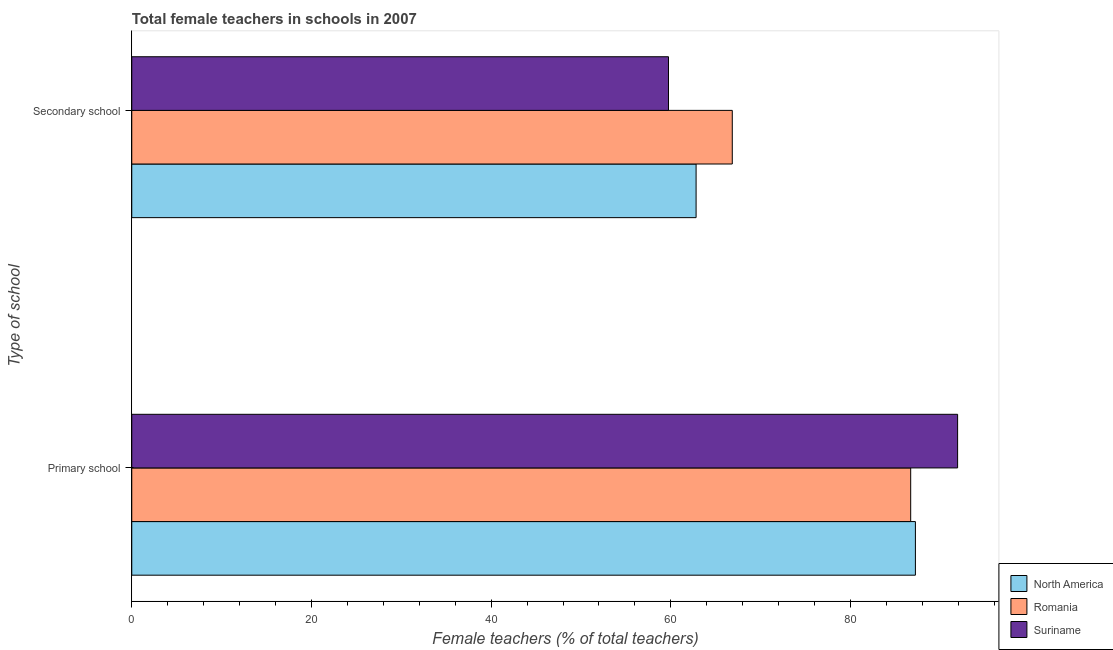How many different coloured bars are there?
Your answer should be very brief. 3. Are the number of bars per tick equal to the number of legend labels?
Your answer should be compact. Yes. Are the number of bars on each tick of the Y-axis equal?
Provide a short and direct response. Yes. How many bars are there on the 2nd tick from the bottom?
Ensure brevity in your answer.  3. What is the label of the 1st group of bars from the top?
Provide a short and direct response. Secondary school. What is the percentage of female teachers in primary schools in Romania?
Offer a terse response. 86.7. Across all countries, what is the maximum percentage of female teachers in primary schools?
Your answer should be very brief. 91.92. Across all countries, what is the minimum percentage of female teachers in primary schools?
Your answer should be very brief. 86.7. In which country was the percentage of female teachers in secondary schools maximum?
Give a very brief answer. Romania. In which country was the percentage of female teachers in secondary schools minimum?
Your response must be concise. Suriname. What is the total percentage of female teachers in secondary schools in the graph?
Offer a very short reply. 189.39. What is the difference between the percentage of female teachers in secondary schools in North America and that in Romania?
Keep it short and to the point. -4.03. What is the difference between the percentage of female teachers in secondary schools in North America and the percentage of female teachers in primary schools in Romania?
Give a very brief answer. -23.89. What is the average percentage of female teachers in primary schools per country?
Offer a terse response. 88.61. What is the difference between the percentage of female teachers in primary schools and percentage of female teachers in secondary schools in Suriname?
Make the answer very short. 32.18. What is the ratio of the percentage of female teachers in primary schools in North America to that in Romania?
Make the answer very short. 1.01. What does the 3rd bar from the top in Primary school represents?
Offer a very short reply. North America. What does the 3rd bar from the bottom in Primary school represents?
Keep it short and to the point. Suriname. How many bars are there?
Your answer should be very brief. 6. What is the difference between two consecutive major ticks on the X-axis?
Make the answer very short. 20. Are the values on the major ticks of X-axis written in scientific E-notation?
Keep it short and to the point. No. Does the graph contain any zero values?
Give a very brief answer. No. Does the graph contain grids?
Keep it short and to the point. No. How many legend labels are there?
Provide a short and direct response. 3. How are the legend labels stacked?
Provide a short and direct response. Vertical. What is the title of the graph?
Offer a very short reply. Total female teachers in schools in 2007. Does "Japan" appear as one of the legend labels in the graph?
Offer a terse response. No. What is the label or title of the X-axis?
Offer a very short reply. Female teachers (% of total teachers). What is the label or title of the Y-axis?
Make the answer very short. Type of school. What is the Female teachers (% of total teachers) in North America in Primary school?
Keep it short and to the point. 87.22. What is the Female teachers (% of total teachers) in Romania in Primary school?
Make the answer very short. 86.7. What is the Female teachers (% of total teachers) of Suriname in Primary school?
Keep it short and to the point. 91.92. What is the Female teachers (% of total teachers) of North America in Secondary school?
Your answer should be compact. 62.81. What is the Female teachers (% of total teachers) in Romania in Secondary school?
Your answer should be compact. 66.84. What is the Female teachers (% of total teachers) in Suriname in Secondary school?
Give a very brief answer. 59.74. Across all Type of school, what is the maximum Female teachers (% of total teachers) of North America?
Your answer should be very brief. 87.22. Across all Type of school, what is the maximum Female teachers (% of total teachers) in Romania?
Offer a terse response. 86.7. Across all Type of school, what is the maximum Female teachers (% of total teachers) of Suriname?
Make the answer very short. 91.92. Across all Type of school, what is the minimum Female teachers (% of total teachers) in North America?
Your answer should be very brief. 62.81. Across all Type of school, what is the minimum Female teachers (% of total teachers) in Romania?
Keep it short and to the point. 66.84. Across all Type of school, what is the minimum Female teachers (% of total teachers) in Suriname?
Provide a short and direct response. 59.74. What is the total Female teachers (% of total teachers) of North America in the graph?
Your response must be concise. 150.03. What is the total Female teachers (% of total teachers) in Romania in the graph?
Give a very brief answer. 153.54. What is the total Female teachers (% of total teachers) in Suriname in the graph?
Keep it short and to the point. 151.66. What is the difference between the Female teachers (% of total teachers) in North America in Primary school and that in Secondary school?
Your answer should be compact. 24.41. What is the difference between the Female teachers (% of total teachers) in Romania in Primary school and that in Secondary school?
Your answer should be very brief. 19.86. What is the difference between the Female teachers (% of total teachers) in Suriname in Primary school and that in Secondary school?
Give a very brief answer. 32.18. What is the difference between the Female teachers (% of total teachers) in North America in Primary school and the Female teachers (% of total teachers) in Romania in Secondary school?
Your answer should be very brief. 20.38. What is the difference between the Female teachers (% of total teachers) in North America in Primary school and the Female teachers (% of total teachers) in Suriname in Secondary school?
Keep it short and to the point. 27.48. What is the difference between the Female teachers (% of total teachers) in Romania in Primary school and the Female teachers (% of total teachers) in Suriname in Secondary school?
Your answer should be very brief. 26.96. What is the average Female teachers (% of total teachers) of North America per Type of school?
Provide a succinct answer. 75.02. What is the average Female teachers (% of total teachers) in Romania per Type of school?
Provide a succinct answer. 76.77. What is the average Female teachers (% of total teachers) of Suriname per Type of school?
Provide a short and direct response. 75.83. What is the difference between the Female teachers (% of total teachers) in North America and Female teachers (% of total teachers) in Romania in Primary school?
Make the answer very short. 0.52. What is the difference between the Female teachers (% of total teachers) of North America and Female teachers (% of total teachers) of Suriname in Primary school?
Offer a terse response. -4.7. What is the difference between the Female teachers (% of total teachers) of Romania and Female teachers (% of total teachers) of Suriname in Primary school?
Ensure brevity in your answer.  -5.22. What is the difference between the Female teachers (% of total teachers) of North America and Female teachers (% of total teachers) of Romania in Secondary school?
Make the answer very short. -4.03. What is the difference between the Female teachers (% of total teachers) of North America and Female teachers (% of total teachers) of Suriname in Secondary school?
Provide a succinct answer. 3.07. What is the difference between the Female teachers (% of total teachers) in Romania and Female teachers (% of total teachers) in Suriname in Secondary school?
Offer a very short reply. 7.1. What is the ratio of the Female teachers (% of total teachers) of North America in Primary school to that in Secondary school?
Ensure brevity in your answer.  1.39. What is the ratio of the Female teachers (% of total teachers) of Romania in Primary school to that in Secondary school?
Provide a short and direct response. 1.3. What is the ratio of the Female teachers (% of total teachers) of Suriname in Primary school to that in Secondary school?
Give a very brief answer. 1.54. What is the difference between the highest and the second highest Female teachers (% of total teachers) of North America?
Make the answer very short. 24.41. What is the difference between the highest and the second highest Female teachers (% of total teachers) of Romania?
Provide a succinct answer. 19.86. What is the difference between the highest and the second highest Female teachers (% of total teachers) of Suriname?
Your answer should be very brief. 32.18. What is the difference between the highest and the lowest Female teachers (% of total teachers) in North America?
Your answer should be compact. 24.41. What is the difference between the highest and the lowest Female teachers (% of total teachers) of Romania?
Keep it short and to the point. 19.86. What is the difference between the highest and the lowest Female teachers (% of total teachers) in Suriname?
Offer a very short reply. 32.18. 